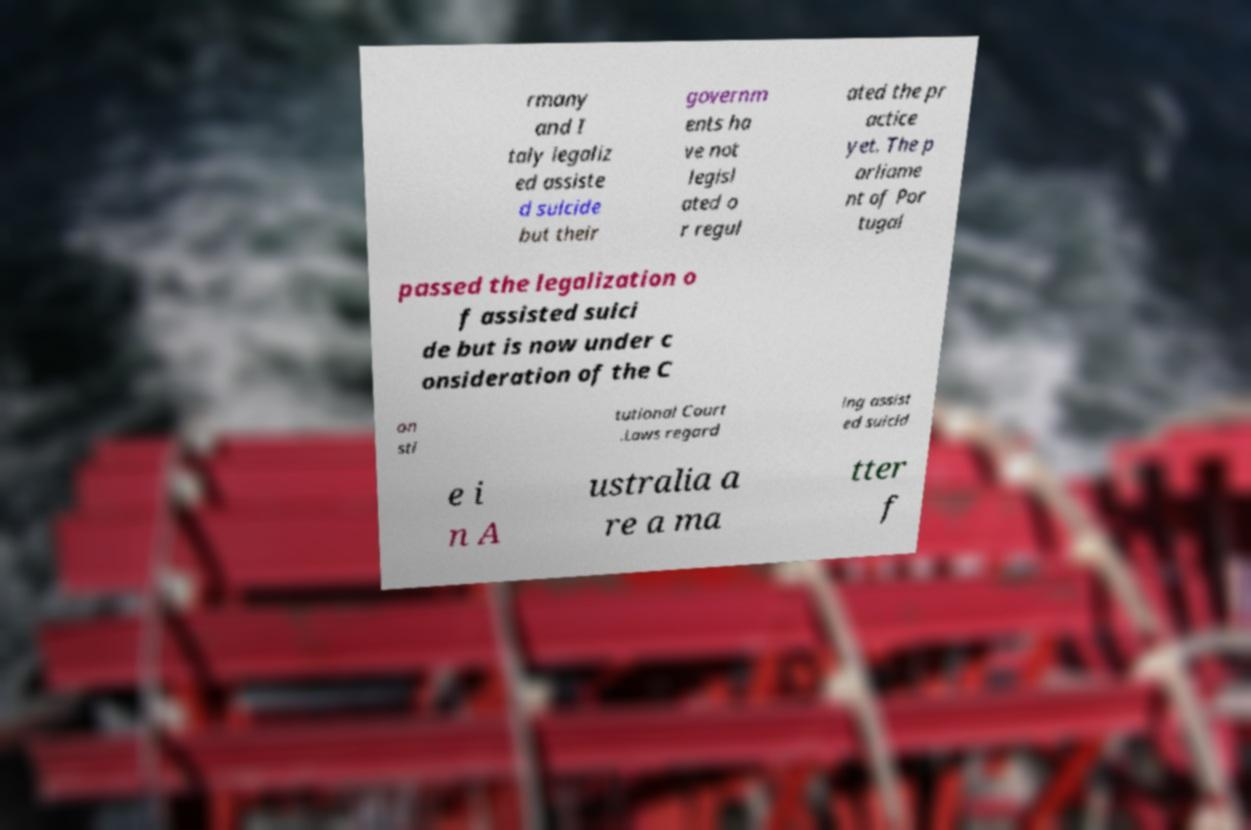Can you accurately transcribe the text from the provided image for me? rmany and I taly legaliz ed assiste d suicide but their governm ents ha ve not legisl ated o r regul ated the pr actice yet. The p arliame nt of Por tugal passed the legalization o f assisted suici de but is now under c onsideration of the C on sti tutional Court .Laws regard ing assist ed suicid e i n A ustralia a re a ma tter f 